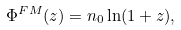<formula> <loc_0><loc_0><loc_500><loc_500>\Phi ^ { F M } ( z ) = n _ { 0 } \ln ( 1 + z ) ,</formula> 